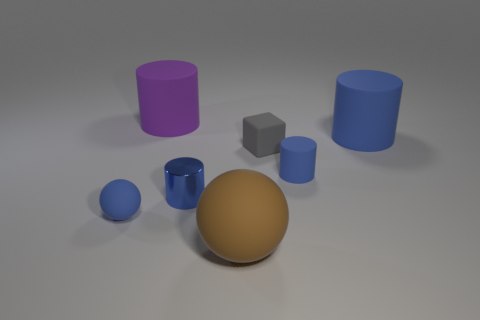There is a large blue object that is the same shape as the large purple matte object; what is it made of?
Your answer should be compact. Rubber. How many large brown rubber things are the same shape as the big purple object?
Provide a succinct answer. 0. What is the material of the gray thing?
Ensure brevity in your answer.  Rubber. There is a metallic thing; is its color the same as the large matte object that is to the right of the small gray matte object?
Give a very brief answer. Yes. How many balls are gray rubber objects or big purple objects?
Ensure brevity in your answer.  0. There is a tiny cylinder that is right of the tiny matte block; what color is it?
Offer a terse response. Blue. The big matte thing that is the same color as the metallic cylinder is what shape?
Your answer should be compact. Cylinder. How many other matte objects are the same size as the gray thing?
Provide a short and direct response. 2. There is a blue thing that is in front of the blue metal object; does it have the same shape as the small blue matte thing that is to the right of the small blue ball?
Provide a succinct answer. No. There is a ball behind the thing that is in front of the thing that is on the left side of the large purple object; what is its material?
Your response must be concise. Rubber. 